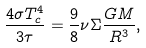<formula> <loc_0><loc_0><loc_500><loc_500>\frac { 4 \sigma T _ { c } ^ { 4 } } { 3 \tau } = \frac { 9 } { 8 } \nu \Sigma \frac { G M } { R ^ { 3 } } ,</formula> 